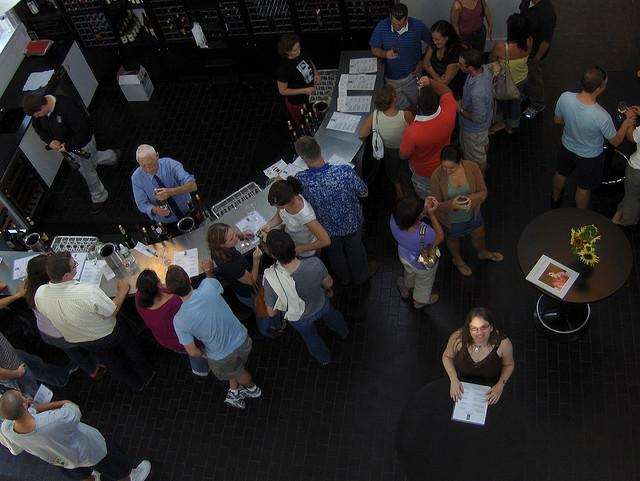What are most people gathered around?

Choices:
A) table
B) bar
C) library
D) kitchen bar 